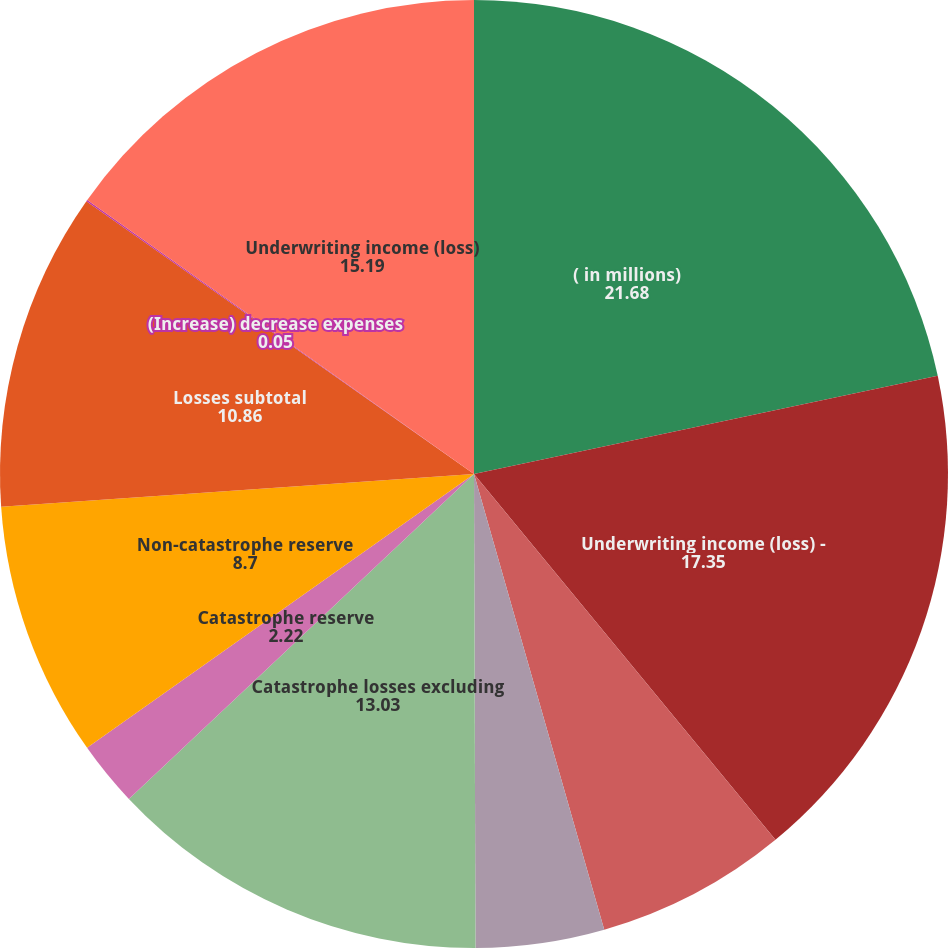Convert chart to OTSL. <chart><loc_0><loc_0><loc_500><loc_500><pie_chart><fcel>( in millions)<fcel>Underwriting income (loss) -<fcel>Increase (decrease) premiums<fcel>Incurred losses excluding<fcel>Catastrophe losses excluding<fcel>Catastrophe reserve<fcel>Non-catastrophe reserve<fcel>Losses subtotal<fcel>(Increase) decrease expenses<fcel>Underwriting income (loss)<nl><fcel>21.68%<fcel>17.35%<fcel>6.54%<fcel>4.38%<fcel>13.03%<fcel>2.22%<fcel>8.7%<fcel>10.86%<fcel>0.05%<fcel>15.19%<nl></chart> 